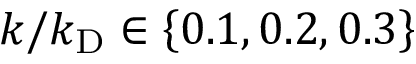Convert formula to latex. <formula><loc_0><loc_0><loc_500><loc_500>k / k _ { D } \in \left \{ 0 . 1 , 0 . 2 , 0 . 3 \right \}</formula> 